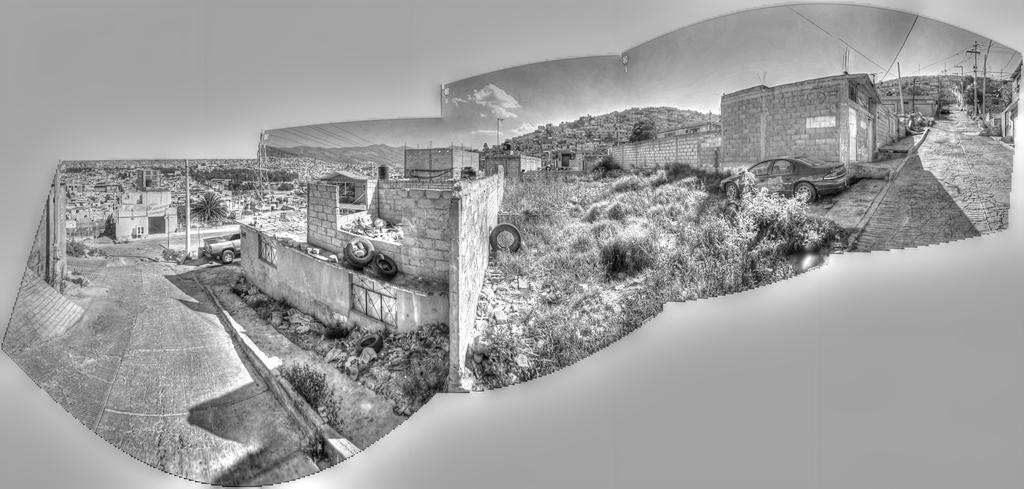What type of infrastructure can be seen in the image? There are roads, walls, and buildings in the image. What kind of vehicles are present in the image? There are vehicles in the image. Can you describe the tires visible in the image? There are tires in the image. What is visible in the background of the image? The sky is visible in the background of the image. What other structures can be seen in the image? There are electric poles with wires in the image. What level of fear is depicted in the image? There is no indication of fear in the image, as it features roads, vehicles, walls, buildings, electric poles, and wires. Can you tell me how many kitties are present in the image? There are no kitties present in the image. 